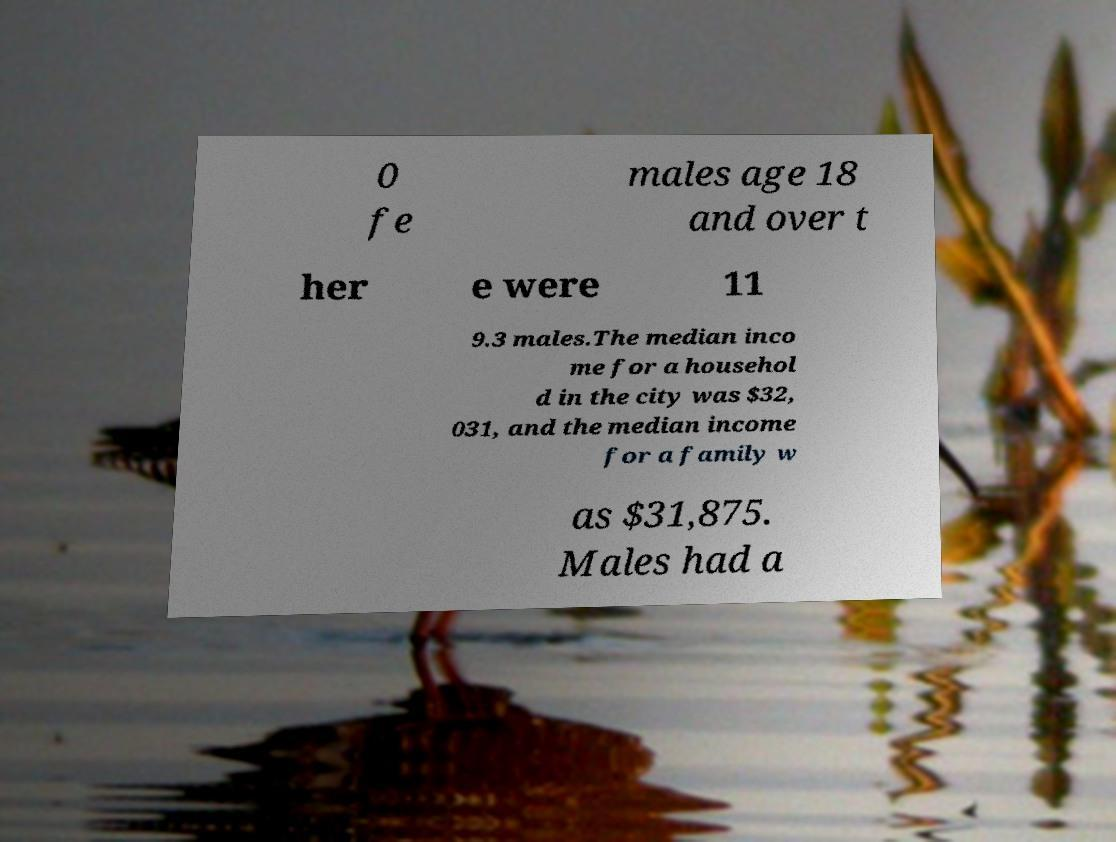Please identify and transcribe the text found in this image. 0 fe males age 18 and over t her e were 11 9.3 males.The median inco me for a househol d in the city was $32, 031, and the median income for a family w as $31,875. Males had a 